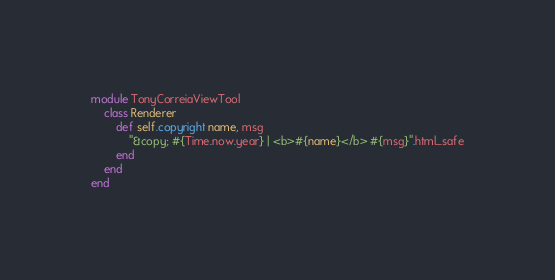Convert code to text. <code><loc_0><loc_0><loc_500><loc_500><_Ruby_>module TonyCorreiaViewTool
	class Renderer
		def self.copyright name, msg
			"&copy; #{Time.now.year} | <b>#{name}</b> #{msg}".html_safe
		end
	end
end</code> 